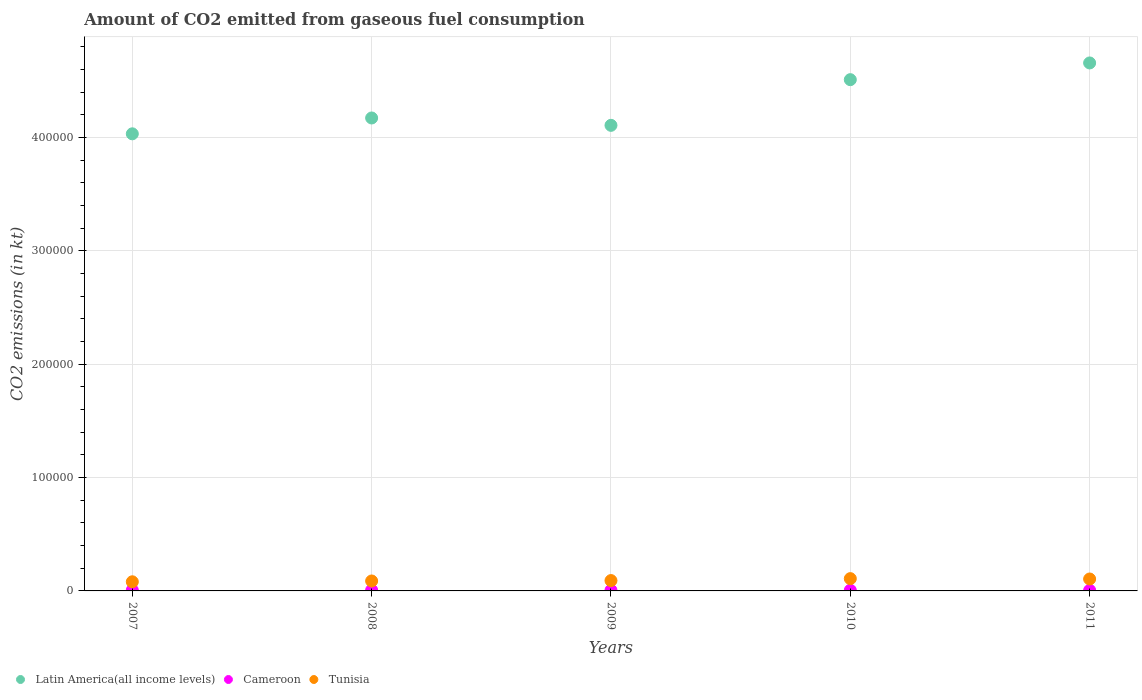How many different coloured dotlines are there?
Provide a short and direct response. 3. What is the amount of CO2 emitted in Latin America(all income levels) in 2011?
Your answer should be very brief. 4.66e+05. Across all years, what is the maximum amount of CO2 emitted in Latin America(all income levels)?
Give a very brief answer. 4.66e+05. Across all years, what is the minimum amount of CO2 emitted in Latin America(all income levels)?
Your answer should be compact. 4.03e+05. In which year was the amount of CO2 emitted in Cameroon maximum?
Your answer should be compact. 2008. In which year was the amount of CO2 emitted in Tunisia minimum?
Offer a terse response. 2007. What is the total amount of CO2 emitted in Tunisia in the graph?
Offer a terse response. 4.73e+04. What is the difference between the amount of CO2 emitted in Latin America(all income levels) in 2009 and that in 2010?
Keep it short and to the point. -4.03e+04. What is the difference between the amount of CO2 emitted in Cameroon in 2009 and the amount of CO2 emitted in Latin America(all income levels) in 2010?
Give a very brief answer. -4.50e+05. What is the average amount of CO2 emitted in Tunisia per year?
Offer a terse response. 9463.79. In the year 2010, what is the difference between the amount of CO2 emitted in Tunisia and amount of CO2 emitted in Cameroon?
Provide a short and direct response. 1.02e+04. What is the ratio of the amount of CO2 emitted in Tunisia in 2007 to that in 2011?
Ensure brevity in your answer.  0.77. What is the difference between the highest and the second highest amount of CO2 emitted in Cameroon?
Offer a terse response. 25.67. What is the difference between the highest and the lowest amount of CO2 emitted in Tunisia?
Provide a short and direct response. 2786.92. Does the amount of CO2 emitted in Cameroon monotonically increase over the years?
Your answer should be very brief. No. How many years are there in the graph?
Offer a terse response. 5. Are the values on the major ticks of Y-axis written in scientific E-notation?
Your answer should be very brief. No. Does the graph contain any zero values?
Offer a very short reply. No. Does the graph contain grids?
Your response must be concise. Yes. Where does the legend appear in the graph?
Provide a succinct answer. Bottom left. What is the title of the graph?
Make the answer very short. Amount of CO2 emitted from gaseous fuel consumption. Does "St. Kitts and Nevis" appear as one of the legend labels in the graph?
Give a very brief answer. No. What is the label or title of the Y-axis?
Make the answer very short. CO2 emissions (in kt). What is the CO2 emissions (in kt) in Latin America(all income levels) in 2007?
Offer a terse response. 4.03e+05. What is the CO2 emissions (in kt) of Cameroon in 2007?
Your answer should be very brief. 685.73. What is the CO2 emissions (in kt) of Tunisia in 2007?
Offer a very short reply. 8056.4. What is the CO2 emissions (in kt) of Latin America(all income levels) in 2008?
Your answer should be compact. 4.17e+05. What is the CO2 emissions (in kt) of Cameroon in 2008?
Your answer should be very brief. 711.4. What is the CO2 emissions (in kt) in Tunisia in 2008?
Give a very brief answer. 8771.46. What is the CO2 emissions (in kt) of Latin America(all income levels) in 2009?
Your answer should be compact. 4.11e+05. What is the CO2 emissions (in kt) of Cameroon in 2009?
Provide a short and direct response. 590.39. What is the CO2 emissions (in kt) in Tunisia in 2009?
Ensure brevity in your answer.  9127.16. What is the CO2 emissions (in kt) of Latin America(all income levels) in 2010?
Your answer should be very brief. 4.51e+05. What is the CO2 emissions (in kt) in Cameroon in 2010?
Provide a succinct answer. 594.05. What is the CO2 emissions (in kt) in Tunisia in 2010?
Your response must be concise. 1.08e+04. What is the CO2 emissions (in kt) of Latin America(all income levels) in 2011?
Make the answer very short. 4.66e+05. What is the CO2 emissions (in kt) in Cameroon in 2011?
Your answer should be compact. 546.38. What is the CO2 emissions (in kt) in Tunisia in 2011?
Your answer should be very brief. 1.05e+04. Across all years, what is the maximum CO2 emissions (in kt) of Latin America(all income levels)?
Provide a short and direct response. 4.66e+05. Across all years, what is the maximum CO2 emissions (in kt) in Cameroon?
Ensure brevity in your answer.  711.4. Across all years, what is the maximum CO2 emissions (in kt) in Tunisia?
Ensure brevity in your answer.  1.08e+04. Across all years, what is the minimum CO2 emissions (in kt) of Latin America(all income levels)?
Your response must be concise. 4.03e+05. Across all years, what is the minimum CO2 emissions (in kt) of Cameroon?
Give a very brief answer. 546.38. Across all years, what is the minimum CO2 emissions (in kt) in Tunisia?
Provide a succinct answer. 8056.4. What is the total CO2 emissions (in kt) in Latin America(all income levels) in the graph?
Your answer should be compact. 2.15e+06. What is the total CO2 emissions (in kt) in Cameroon in the graph?
Provide a succinct answer. 3127.95. What is the total CO2 emissions (in kt) in Tunisia in the graph?
Provide a succinct answer. 4.73e+04. What is the difference between the CO2 emissions (in kt) of Latin America(all income levels) in 2007 and that in 2008?
Ensure brevity in your answer.  -1.40e+04. What is the difference between the CO2 emissions (in kt) in Cameroon in 2007 and that in 2008?
Make the answer very short. -25.67. What is the difference between the CO2 emissions (in kt) of Tunisia in 2007 and that in 2008?
Your answer should be compact. -715.07. What is the difference between the CO2 emissions (in kt) in Latin America(all income levels) in 2007 and that in 2009?
Your answer should be compact. -7484.34. What is the difference between the CO2 emissions (in kt) of Cameroon in 2007 and that in 2009?
Provide a short and direct response. 95.34. What is the difference between the CO2 emissions (in kt) in Tunisia in 2007 and that in 2009?
Offer a very short reply. -1070.76. What is the difference between the CO2 emissions (in kt) of Latin America(all income levels) in 2007 and that in 2010?
Ensure brevity in your answer.  -4.78e+04. What is the difference between the CO2 emissions (in kt) in Cameroon in 2007 and that in 2010?
Offer a terse response. 91.67. What is the difference between the CO2 emissions (in kt) of Tunisia in 2007 and that in 2010?
Your response must be concise. -2786.92. What is the difference between the CO2 emissions (in kt) of Latin America(all income levels) in 2007 and that in 2011?
Ensure brevity in your answer.  -6.25e+04. What is the difference between the CO2 emissions (in kt) of Cameroon in 2007 and that in 2011?
Give a very brief answer. 139.35. What is the difference between the CO2 emissions (in kt) of Tunisia in 2007 and that in 2011?
Provide a succinct answer. -2464.22. What is the difference between the CO2 emissions (in kt) in Latin America(all income levels) in 2008 and that in 2009?
Make the answer very short. 6486.17. What is the difference between the CO2 emissions (in kt) in Cameroon in 2008 and that in 2009?
Offer a very short reply. 121.01. What is the difference between the CO2 emissions (in kt) of Tunisia in 2008 and that in 2009?
Provide a succinct answer. -355.7. What is the difference between the CO2 emissions (in kt) in Latin America(all income levels) in 2008 and that in 2010?
Your answer should be very brief. -3.38e+04. What is the difference between the CO2 emissions (in kt) in Cameroon in 2008 and that in 2010?
Give a very brief answer. 117.34. What is the difference between the CO2 emissions (in kt) of Tunisia in 2008 and that in 2010?
Your answer should be compact. -2071.86. What is the difference between the CO2 emissions (in kt) in Latin America(all income levels) in 2008 and that in 2011?
Make the answer very short. -4.85e+04. What is the difference between the CO2 emissions (in kt) in Cameroon in 2008 and that in 2011?
Provide a succinct answer. 165.01. What is the difference between the CO2 emissions (in kt) in Tunisia in 2008 and that in 2011?
Offer a terse response. -1749.16. What is the difference between the CO2 emissions (in kt) of Latin America(all income levels) in 2009 and that in 2010?
Give a very brief answer. -4.03e+04. What is the difference between the CO2 emissions (in kt) in Cameroon in 2009 and that in 2010?
Give a very brief answer. -3.67. What is the difference between the CO2 emissions (in kt) of Tunisia in 2009 and that in 2010?
Offer a terse response. -1716.16. What is the difference between the CO2 emissions (in kt) of Latin America(all income levels) in 2009 and that in 2011?
Your answer should be very brief. -5.50e+04. What is the difference between the CO2 emissions (in kt) of Cameroon in 2009 and that in 2011?
Your response must be concise. 44. What is the difference between the CO2 emissions (in kt) in Tunisia in 2009 and that in 2011?
Your response must be concise. -1393.46. What is the difference between the CO2 emissions (in kt) of Latin America(all income levels) in 2010 and that in 2011?
Offer a terse response. -1.47e+04. What is the difference between the CO2 emissions (in kt) in Cameroon in 2010 and that in 2011?
Offer a terse response. 47.67. What is the difference between the CO2 emissions (in kt) of Tunisia in 2010 and that in 2011?
Give a very brief answer. 322.7. What is the difference between the CO2 emissions (in kt) of Latin America(all income levels) in 2007 and the CO2 emissions (in kt) of Cameroon in 2008?
Ensure brevity in your answer.  4.02e+05. What is the difference between the CO2 emissions (in kt) of Latin America(all income levels) in 2007 and the CO2 emissions (in kt) of Tunisia in 2008?
Keep it short and to the point. 3.94e+05. What is the difference between the CO2 emissions (in kt) of Cameroon in 2007 and the CO2 emissions (in kt) of Tunisia in 2008?
Provide a succinct answer. -8085.73. What is the difference between the CO2 emissions (in kt) in Latin America(all income levels) in 2007 and the CO2 emissions (in kt) in Cameroon in 2009?
Make the answer very short. 4.03e+05. What is the difference between the CO2 emissions (in kt) in Latin America(all income levels) in 2007 and the CO2 emissions (in kt) in Tunisia in 2009?
Give a very brief answer. 3.94e+05. What is the difference between the CO2 emissions (in kt) of Cameroon in 2007 and the CO2 emissions (in kt) of Tunisia in 2009?
Provide a short and direct response. -8441.43. What is the difference between the CO2 emissions (in kt) in Latin America(all income levels) in 2007 and the CO2 emissions (in kt) in Cameroon in 2010?
Keep it short and to the point. 4.03e+05. What is the difference between the CO2 emissions (in kt) of Latin America(all income levels) in 2007 and the CO2 emissions (in kt) of Tunisia in 2010?
Keep it short and to the point. 3.92e+05. What is the difference between the CO2 emissions (in kt) in Cameroon in 2007 and the CO2 emissions (in kt) in Tunisia in 2010?
Keep it short and to the point. -1.02e+04. What is the difference between the CO2 emissions (in kt) in Latin America(all income levels) in 2007 and the CO2 emissions (in kt) in Cameroon in 2011?
Provide a succinct answer. 4.03e+05. What is the difference between the CO2 emissions (in kt) in Latin America(all income levels) in 2007 and the CO2 emissions (in kt) in Tunisia in 2011?
Your answer should be very brief. 3.93e+05. What is the difference between the CO2 emissions (in kt) of Cameroon in 2007 and the CO2 emissions (in kt) of Tunisia in 2011?
Offer a very short reply. -9834.89. What is the difference between the CO2 emissions (in kt) in Latin America(all income levels) in 2008 and the CO2 emissions (in kt) in Cameroon in 2009?
Your answer should be very brief. 4.17e+05. What is the difference between the CO2 emissions (in kt) in Latin America(all income levels) in 2008 and the CO2 emissions (in kt) in Tunisia in 2009?
Provide a short and direct response. 4.08e+05. What is the difference between the CO2 emissions (in kt) of Cameroon in 2008 and the CO2 emissions (in kt) of Tunisia in 2009?
Provide a succinct answer. -8415.76. What is the difference between the CO2 emissions (in kt) of Latin America(all income levels) in 2008 and the CO2 emissions (in kt) of Cameroon in 2010?
Your answer should be compact. 4.17e+05. What is the difference between the CO2 emissions (in kt) in Latin America(all income levels) in 2008 and the CO2 emissions (in kt) in Tunisia in 2010?
Your answer should be compact. 4.06e+05. What is the difference between the CO2 emissions (in kt) in Cameroon in 2008 and the CO2 emissions (in kt) in Tunisia in 2010?
Ensure brevity in your answer.  -1.01e+04. What is the difference between the CO2 emissions (in kt) in Latin America(all income levels) in 2008 and the CO2 emissions (in kt) in Cameroon in 2011?
Your answer should be compact. 4.17e+05. What is the difference between the CO2 emissions (in kt) of Latin America(all income levels) in 2008 and the CO2 emissions (in kt) of Tunisia in 2011?
Your answer should be compact. 4.07e+05. What is the difference between the CO2 emissions (in kt) in Cameroon in 2008 and the CO2 emissions (in kt) in Tunisia in 2011?
Offer a very short reply. -9809.23. What is the difference between the CO2 emissions (in kt) in Latin America(all income levels) in 2009 and the CO2 emissions (in kt) in Cameroon in 2010?
Offer a terse response. 4.10e+05. What is the difference between the CO2 emissions (in kt) of Latin America(all income levels) in 2009 and the CO2 emissions (in kt) of Tunisia in 2010?
Provide a succinct answer. 4.00e+05. What is the difference between the CO2 emissions (in kt) of Cameroon in 2009 and the CO2 emissions (in kt) of Tunisia in 2010?
Offer a terse response. -1.03e+04. What is the difference between the CO2 emissions (in kt) in Latin America(all income levels) in 2009 and the CO2 emissions (in kt) in Cameroon in 2011?
Make the answer very short. 4.10e+05. What is the difference between the CO2 emissions (in kt) in Latin America(all income levels) in 2009 and the CO2 emissions (in kt) in Tunisia in 2011?
Offer a terse response. 4.00e+05. What is the difference between the CO2 emissions (in kt) in Cameroon in 2009 and the CO2 emissions (in kt) in Tunisia in 2011?
Ensure brevity in your answer.  -9930.24. What is the difference between the CO2 emissions (in kt) of Latin America(all income levels) in 2010 and the CO2 emissions (in kt) of Cameroon in 2011?
Offer a very short reply. 4.50e+05. What is the difference between the CO2 emissions (in kt) in Latin America(all income levels) in 2010 and the CO2 emissions (in kt) in Tunisia in 2011?
Offer a terse response. 4.40e+05. What is the difference between the CO2 emissions (in kt) in Cameroon in 2010 and the CO2 emissions (in kt) in Tunisia in 2011?
Give a very brief answer. -9926.57. What is the average CO2 emissions (in kt) in Latin America(all income levels) per year?
Make the answer very short. 4.29e+05. What is the average CO2 emissions (in kt) of Cameroon per year?
Your response must be concise. 625.59. What is the average CO2 emissions (in kt) in Tunisia per year?
Make the answer very short. 9463.79. In the year 2007, what is the difference between the CO2 emissions (in kt) in Latin America(all income levels) and CO2 emissions (in kt) in Cameroon?
Give a very brief answer. 4.02e+05. In the year 2007, what is the difference between the CO2 emissions (in kt) of Latin America(all income levels) and CO2 emissions (in kt) of Tunisia?
Keep it short and to the point. 3.95e+05. In the year 2007, what is the difference between the CO2 emissions (in kt) of Cameroon and CO2 emissions (in kt) of Tunisia?
Provide a short and direct response. -7370.67. In the year 2008, what is the difference between the CO2 emissions (in kt) in Latin America(all income levels) and CO2 emissions (in kt) in Cameroon?
Your answer should be very brief. 4.16e+05. In the year 2008, what is the difference between the CO2 emissions (in kt) in Latin America(all income levels) and CO2 emissions (in kt) in Tunisia?
Keep it short and to the point. 4.08e+05. In the year 2008, what is the difference between the CO2 emissions (in kt) in Cameroon and CO2 emissions (in kt) in Tunisia?
Provide a succinct answer. -8060.07. In the year 2009, what is the difference between the CO2 emissions (in kt) of Latin America(all income levels) and CO2 emissions (in kt) of Cameroon?
Provide a succinct answer. 4.10e+05. In the year 2009, what is the difference between the CO2 emissions (in kt) in Latin America(all income levels) and CO2 emissions (in kt) in Tunisia?
Offer a very short reply. 4.02e+05. In the year 2009, what is the difference between the CO2 emissions (in kt) in Cameroon and CO2 emissions (in kt) in Tunisia?
Ensure brevity in your answer.  -8536.78. In the year 2010, what is the difference between the CO2 emissions (in kt) of Latin America(all income levels) and CO2 emissions (in kt) of Cameroon?
Your response must be concise. 4.50e+05. In the year 2010, what is the difference between the CO2 emissions (in kt) of Latin America(all income levels) and CO2 emissions (in kt) of Tunisia?
Your answer should be very brief. 4.40e+05. In the year 2010, what is the difference between the CO2 emissions (in kt) in Cameroon and CO2 emissions (in kt) in Tunisia?
Ensure brevity in your answer.  -1.02e+04. In the year 2011, what is the difference between the CO2 emissions (in kt) of Latin America(all income levels) and CO2 emissions (in kt) of Cameroon?
Your response must be concise. 4.65e+05. In the year 2011, what is the difference between the CO2 emissions (in kt) of Latin America(all income levels) and CO2 emissions (in kt) of Tunisia?
Make the answer very short. 4.55e+05. In the year 2011, what is the difference between the CO2 emissions (in kt) in Cameroon and CO2 emissions (in kt) in Tunisia?
Keep it short and to the point. -9974.24. What is the ratio of the CO2 emissions (in kt) in Latin America(all income levels) in 2007 to that in 2008?
Keep it short and to the point. 0.97. What is the ratio of the CO2 emissions (in kt) in Cameroon in 2007 to that in 2008?
Your response must be concise. 0.96. What is the ratio of the CO2 emissions (in kt) of Tunisia in 2007 to that in 2008?
Keep it short and to the point. 0.92. What is the ratio of the CO2 emissions (in kt) of Latin America(all income levels) in 2007 to that in 2009?
Offer a very short reply. 0.98. What is the ratio of the CO2 emissions (in kt) in Cameroon in 2007 to that in 2009?
Offer a very short reply. 1.16. What is the ratio of the CO2 emissions (in kt) of Tunisia in 2007 to that in 2009?
Your answer should be very brief. 0.88. What is the ratio of the CO2 emissions (in kt) in Latin America(all income levels) in 2007 to that in 2010?
Offer a very short reply. 0.89. What is the ratio of the CO2 emissions (in kt) of Cameroon in 2007 to that in 2010?
Your response must be concise. 1.15. What is the ratio of the CO2 emissions (in kt) of Tunisia in 2007 to that in 2010?
Your response must be concise. 0.74. What is the ratio of the CO2 emissions (in kt) of Latin America(all income levels) in 2007 to that in 2011?
Provide a short and direct response. 0.87. What is the ratio of the CO2 emissions (in kt) of Cameroon in 2007 to that in 2011?
Your response must be concise. 1.25. What is the ratio of the CO2 emissions (in kt) in Tunisia in 2007 to that in 2011?
Give a very brief answer. 0.77. What is the ratio of the CO2 emissions (in kt) in Latin America(all income levels) in 2008 to that in 2009?
Your answer should be very brief. 1.02. What is the ratio of the CO2 emissions (in kt) in Cameroon in 2008 to that in 2009?
Ensure brevity in your answer.  1.21. What is the ratio of the CO2 emissions (in kt) in Tunisia in 2008 to that in 2009?
Provide a succinct answer. 0.96. What is the ratio of the CO2 emissions (in kt) in Latin America(all income levels) in 2008 to that in 2010?
Offer a terse response. 0.93. What is the ratio of the CO2 emissions (in kt) in Cameroon in 2008 to that in 2010?
Your answer should be very brief. 1.2. What is the ratio of the CO2 emissions (in kt) of Tunisia in 2008 to that in 2010?
Offer a very short reply. 0.81. What is the ratio of the CO2 emissions (in kt) of Latin America(all income levels) in 2008 to that in 2011?
Provide a short and direct response. 0.9. What is the ratio of the CO2 emissions (in kt) of Cameroon in 2008 to that in 2011?
Ensure brevity in your answer.  1.3. What is the ratio of the CO2 emissions (in kt) of Tunisia in 2008 to that in 2011?
Offer a very short reply. 0.83. What is the ratio of the CO2 emissions (in kt) of Latin America(all income levels) in 2009 to that in 2010?
Give a very brief answer. 0.91. What is the ratio of the CO2 emissions (in kt) in Tunisia in 2009 to that in 2010?
Keep it short and to the point. 0.84. What is the ratio of the CO2 emissions (in kt) in Latin America(all income levels) in 2009 to that in 2011?
Make the answer very short. 0.88. What is the ratio of the CO2 emissions (in kt) in Cameroon in 2009 to that in 2011?
Keep it short and to the point. 1.08. What is the ratio of the CO2 emissions (in kt) of Tunisia in 2009 to that in 2011?
Offer a terse response. 0.87. What is the ratio of the CO2 emissions (in kt) in Latin America(all income levels) in 2010 to that in 2011?
Provide a short and direct response. 0.97. What is the ratio of the CO2 emissions (in kt) in Cameroon in 2010 to that in 2011?
Offer a terse response. 1.09. What is the ratio of the CO2 emissions (in kt) in Tunisia in 2010 to that in 2011?
Offer a terse response. 1.03. What is the difference between the highest and the second highest CO2 emissions (in kt) in Latin America(all income levels)?
Keep it short and to the point. 1.47e+04. What is the difference between the highest and the second highest CO2 emissions (in kt) in Cameroon?
Offer a very short reply. 25.67. What is the difference between the highest and the second highest CO2 emissions (in kt) of Tunisia?
Your response must be concise. 322.7. What is the difference between the highest and the lowest CO2 emissions (in kt) of Latin America(all income levels)?
Offer a terse response. 6.25e+04. What is the difference between the highest and the lowest CO2 emissions (in kt) in Cameroon?
Your answer should be compact. 165.01. What is the difference between the highest and the lowest CO2 emissions (in kt) of Tunisia?
Your answer should be compact. 2786.92. 